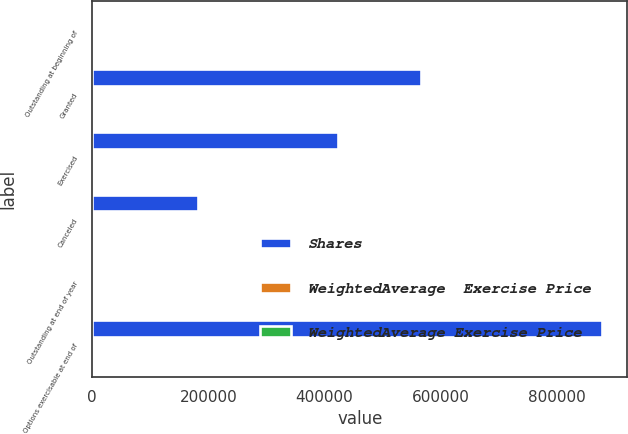Convert chart to OTSL. <chart><loc_0><loc_0><loc_500><loc_500><stacked_bar_chart><ecel><fcel>Outstanding at beginning of<fcel>Granted<fcel>Exercised<fcel>Canceled<fcel>Outstanding at end of year<fcel>Options exercisable at end of<nl><fcel>Shares<fcel>26.195<fcel>565200<fcel>422586<fcel>182837<fcel>26.195<fcel>877068<nl><fcel>WeightedAverage  Exercise Price<fcel>25.37<fcel>48.62<fcel>20.26<fcel>29.85<fcel>31.04<fcel>23.11<nl><fcel>WeightedAverage Exercise Price<fcel>19.34<fcel>27.02<fcel>17.2<fcel>21.92<fcel>21.61<fcel>17.64<nl></chart> 